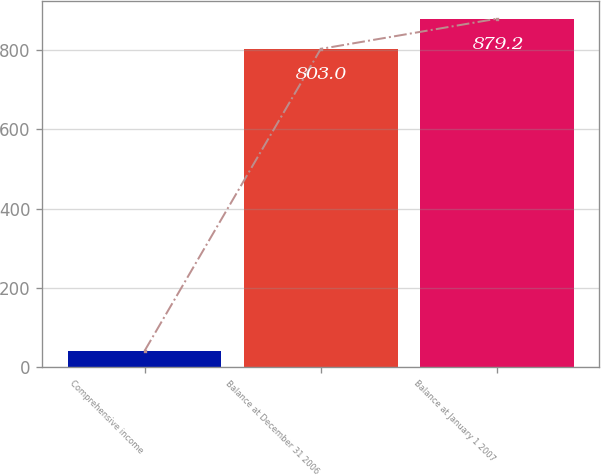<chart> <loc_0><loc_0><loc_500><loc_500><bar_chart><fcel>Comprehensive income<fcel>Balance at December 31 2006<fcel>Balance at January 1 2007<nl><fcel>41<fcel>803<fcel>879.2<nl></chart> 